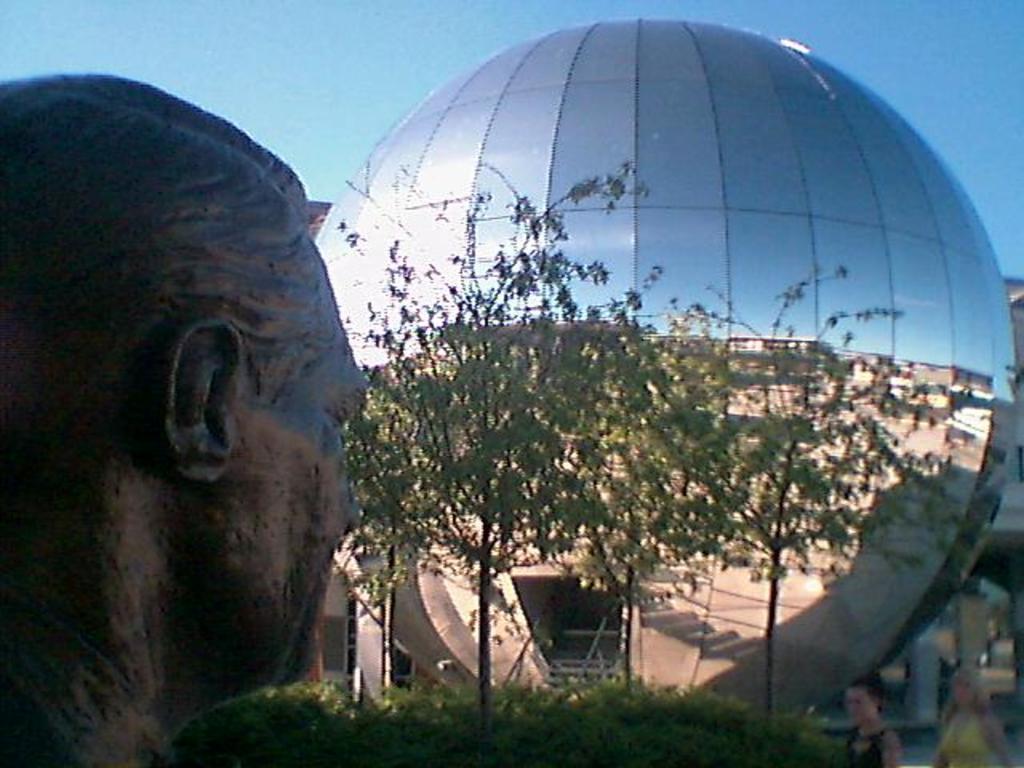Please provide a concise description of this image. In this picture we can see a statue here, in the background there is a building, we can see a tree here, at the right bottom there are two persons, we can see glass here, there is the sky at the top of the picture. 